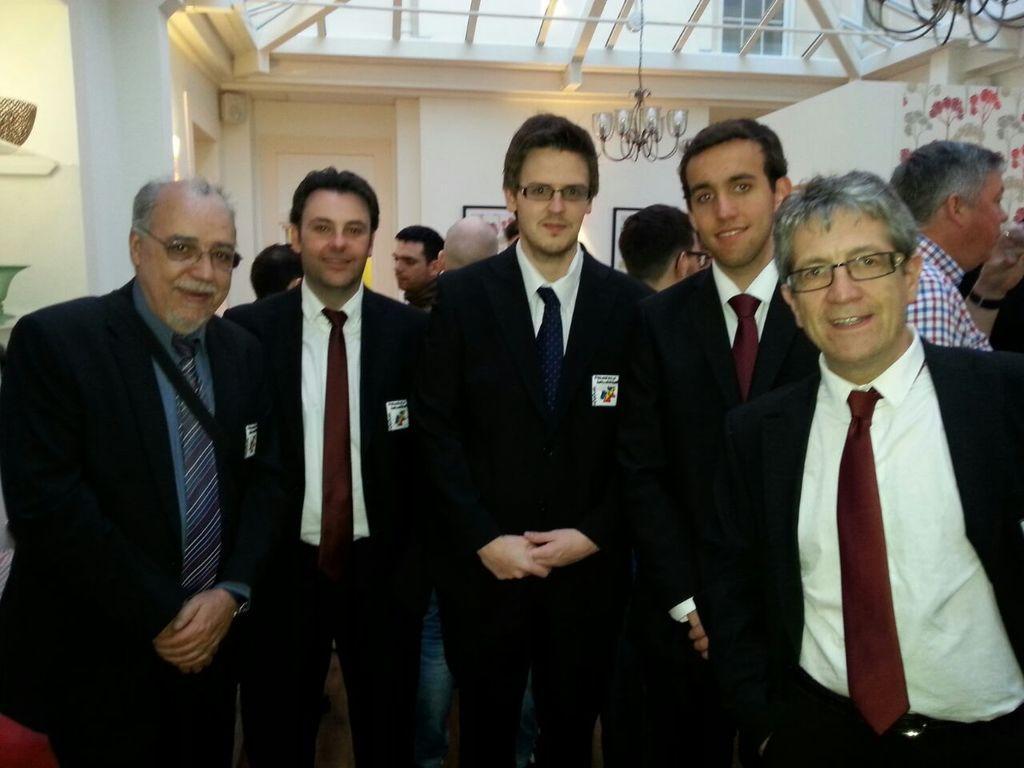Describe this image in one or two sentences. In this image, we can see few people are in suit are watching and smiling. Background we can see people, walls, photo frames, few objects, chandelier and rods. Here we can see the glass window. 